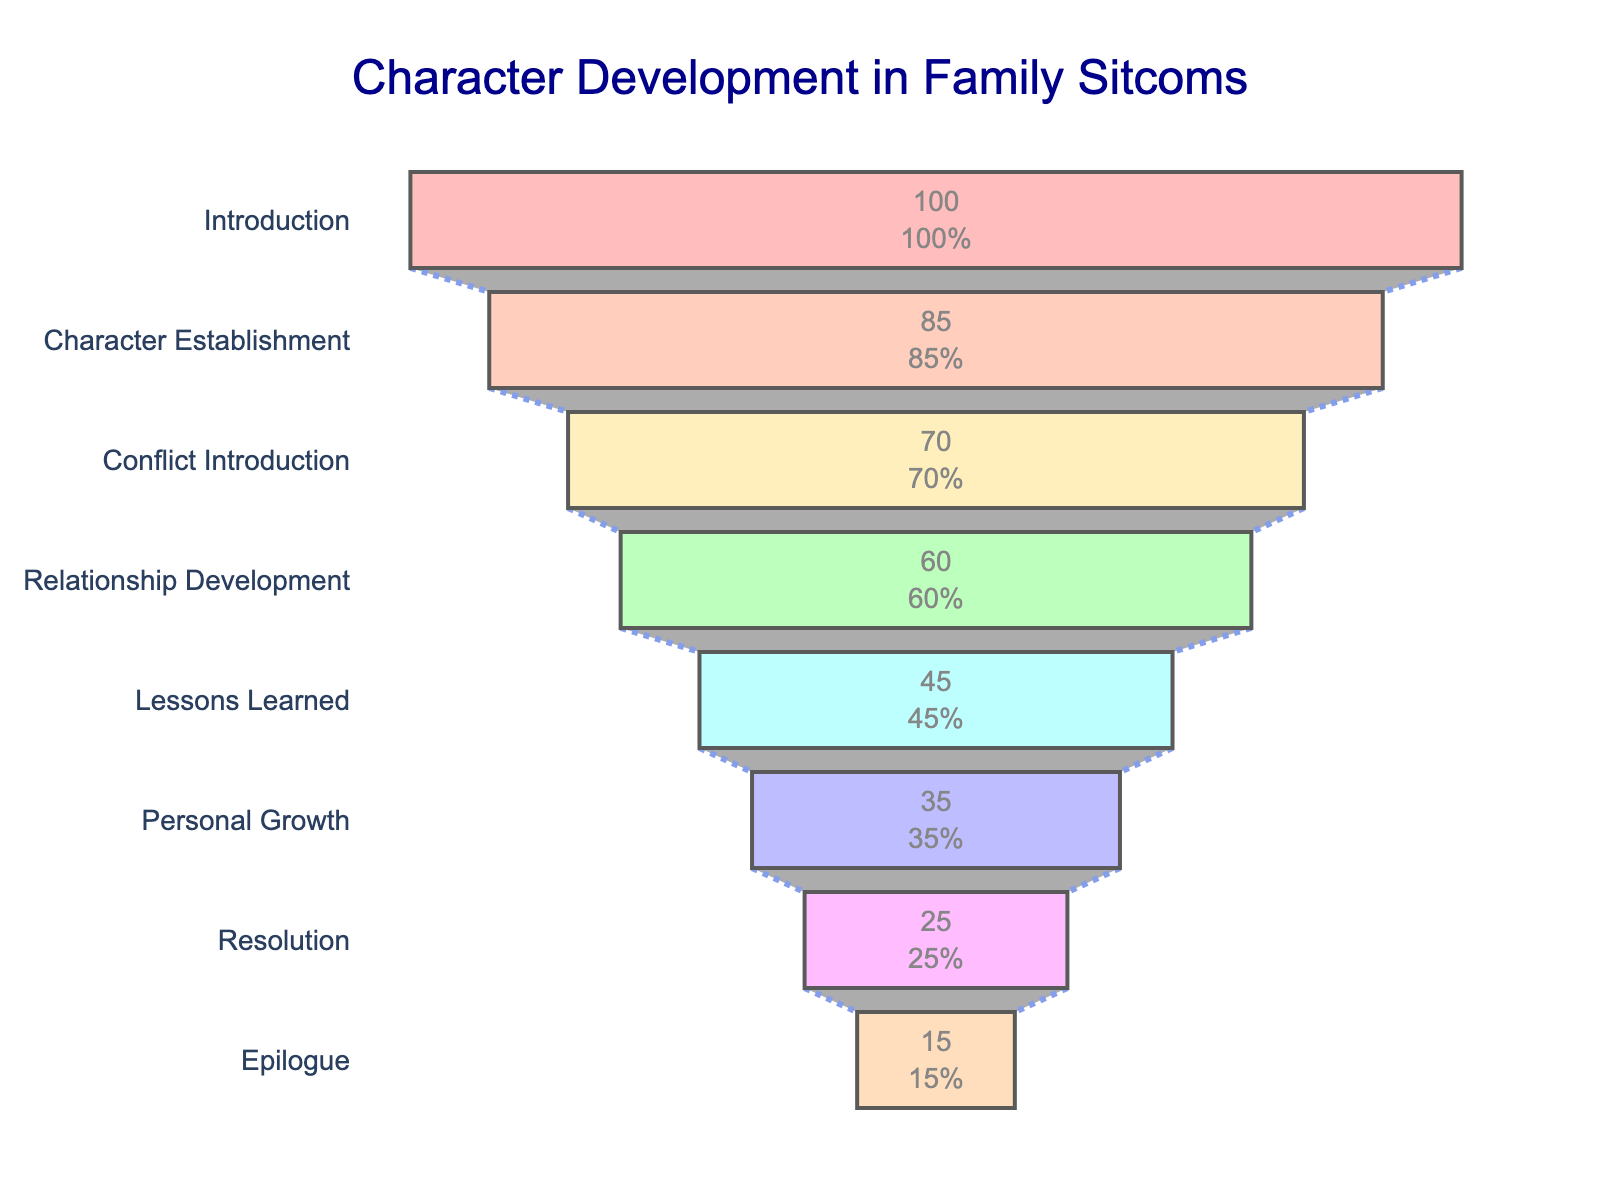what's the title of the funnel chart? The title of the funnel chart is usually displayed at the top of the figure. In this figure, it reads "Character Development in Family Sitcoms".
Answer: Character Development in Family Sitcoms how many stages are represented in the funnel chart? We can determine the number of stages by counting the distinct stages listed on the y-axis: Introduction, Character Establishment, Conflict Introduction, Relationship Development, Lessons Learned, Personal Growth, Resolution, and Epilogue.
Answer: 8 which stage has the most characters? We can find the stage with the most characters by looking at the x-axis values. The widest bar, representing the highest number of characters, corresponds to the "Introduction" stage.
Answer: Introduction how many characters do we have in the "Lessons Learned" stage? Refer to the x-axis value for "Lessons Learned". It shows that there are 45 characters in this stage.
Answer: 45 how many more characters are in the "Character Establishment" stage than in the "Personal Growth" stage? Subtract the number of characters in "Personal Growth" (35) from those in "Character Establishment" (85): 85 - 35 = 50.
Answer: 50 what's the percentage of characters in the "Conflict Introduction" stage relative to the "Introduction" stage? Calculate the percentage by dividing the number of characters in "Conflict Introduction" (70) by the number of characters in "Introduction" (100) and multiplying by 100: (70/100) * 100 = 70%.
Answer: 70% which stage has the least number of characters? The smallest value on the x-axis represents the stage with the least number of characters. The "Epilogue" stage has the least characters with a value of 15.
Answer: Epilogue what's the total number of characters from "Lessons Learned" to "Epilogue"? Sum the number of characters from "Lessons Learned" (45), "Personal Growth" (35), "Resolution" (25), and "Epilogue" (15): 45 + 35 + 25 + 15 = 120.
Answer: 120 what's the percentage decrease in characters from "Introduction" to "Resolution"? Calculate the decrease in characters first: 100 - 25 = 75. Then, divide this decrease by the original number in "Introduction" (100) and multiply by 100: (75/100) * 100 = 75%.
Answer: 75% 